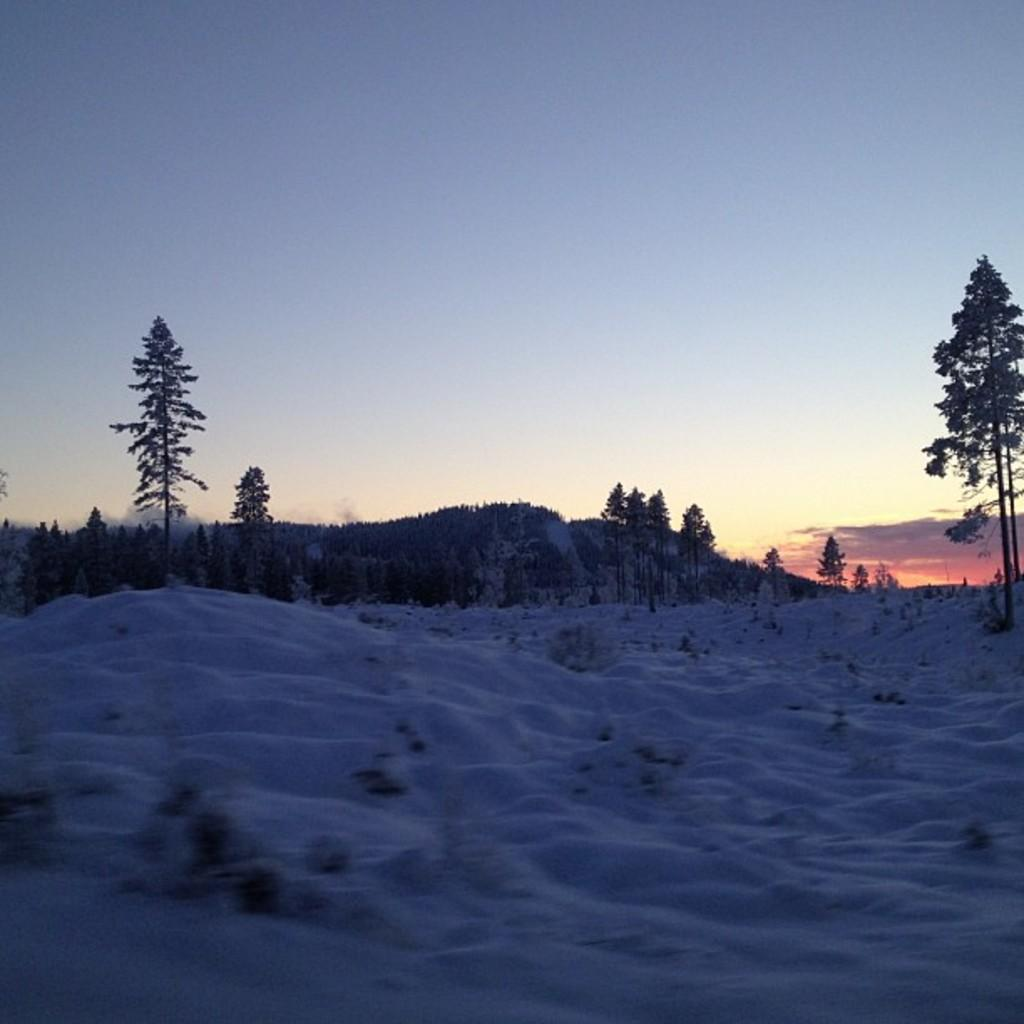What type of picture is shown in the image? The image is a sunset picture. How would you describe the scenery in the image? The scenery is beautiful. What type of vegetation can be seen in the image? There are trees in the image. What is the weather like in the image? The presence of snow everywhere in the image suggests a cold and snowy environment. Can you see any feathers falling from the trees in the image? There are no feathers visible in the image; it features a sunset with snow-covered trees. How many apples can be seen hanging from the branches of the trees in the image? There are no apples present in the image; it features a sunset with snow-covered trees. 